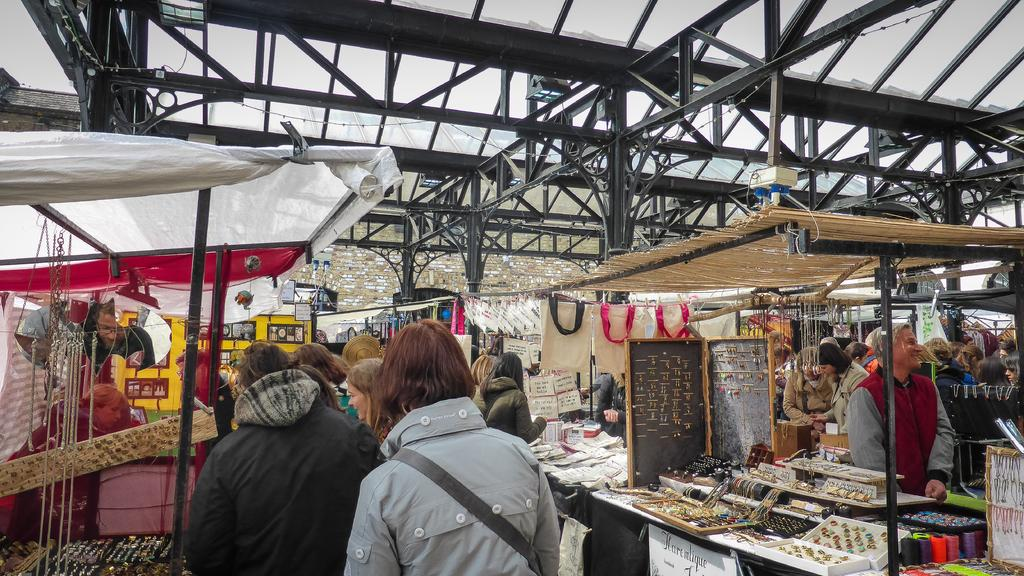How many people are in the group that is visible in the image? There is a group of people standing in the image, but the exact number cannot be determined from the provided facts. What type of objects can be seen hanging in the image? Chains, earrings, and rings are visible in the image. What type of material is visible in the image? Threads are visible in the image. What type of structures are present in the image? There are tents and a shed in the image. What is on the table in the image? There are objects on a table in the image, but their specific nature cannot be determined from the provided facts. What type of hope can be seen in the image? There is no reference to hope in the image, so it cannot be determined from the provided facts. What impulse is driving the people in the image? There is no information about the people's motivations or impulses in the image, so it cannot be determined from the provided facts. 